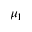<formula> <loc_0><loc_0><loc_500><loc_500>\mu _ { 1 }</formula> 